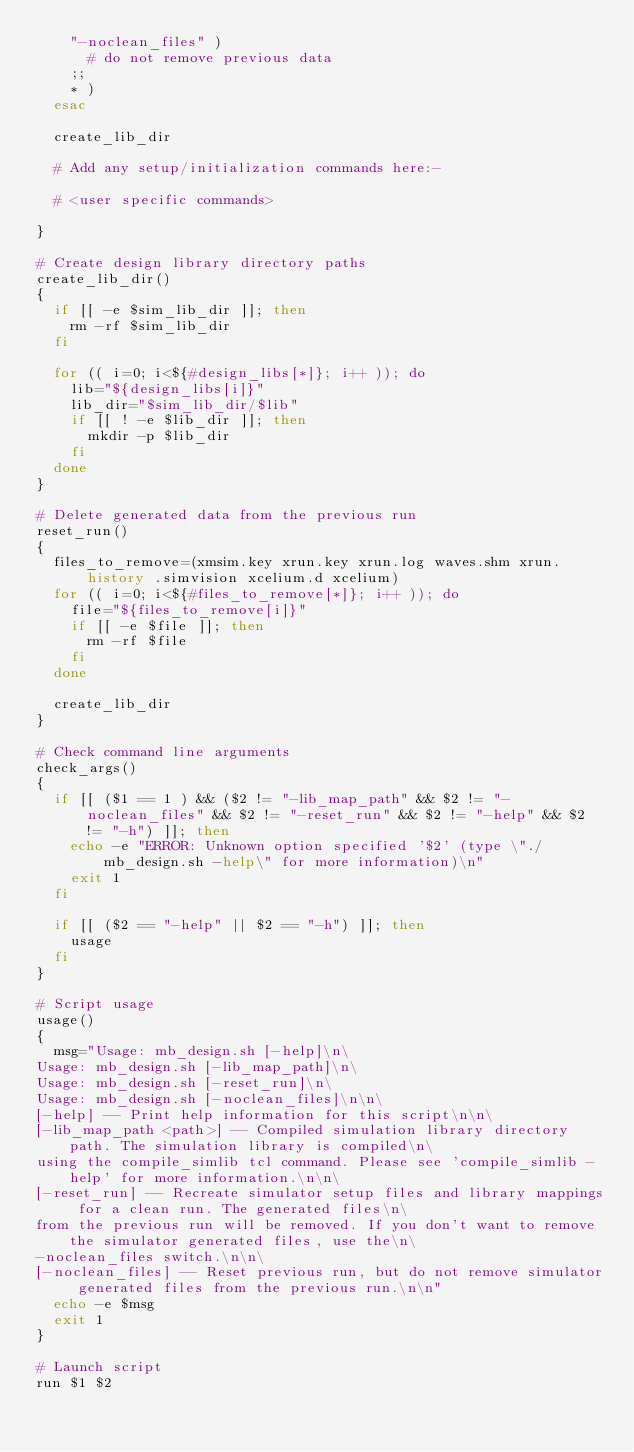<code> <loc_0><loc_0><loc_500><loc_500><_Bash_>    "-noclean_files" )
      # do not remove previous data
    ;;
    * )
  esac

  create_lib_dir

  # Add any setup/initialization commands here:-

  # <user specific commands>

}

# Create design library directory paths
create_lib_dir()
{
  if [[ -e $sim_lib_dir ]]; then
    rm -rf $sim_lib_dir
  fi

  for (( i=0; i<${#design_libs[*]}; i++ )); do
    lib="${design_libs[i]}"
    lib_dir="$sim_lib_dir/$lib"
    if [[ ! -e $lib_dir ]]; then
      mkdir -p $lib_dir
    fi
  done
}

# Delete generated data from the previous run
reset_run()
{
  files_to_remove=(xmsim.key xrun.key xrun.log waves.shm xrun.history .simvision xcelium.d xcelium)
  for (( i=0; i<${#files_to_remove[*]}; i++ )); do
    file="${files_to_remove[i]}"
    if [[ -e $file ]]; then
      rm -rf $file
    fi
  done

  create_lib_dir
}

# Check command line arguments
check_args()
{
  if [[ ($1 == 1 ) && ($2 != "-lib_map_path" && $2 != "-noclean_files" && $2 != "-reset_run" && $2 != "-help" && $2 != "-h") ]]; then
    echo -e "ERROR: Unknown option specified '$2' (type \"./mb_design.sh -help\" for more information)\n"
    exit 1
  fi

  if [[ ($2 == "-help" || $2 == "-h") ]]; then
    usage
  fi
}

# Script usage
usage()
{
  msg="Usage: mb_design.sh [-help]\n\
Usage: mb_design.sh [-lib_map_path]\n\
Usage: mb_design.sh [-reset_run]\n\
Usage: mb_design.sh [-noclean_files]\n\n\
[-help] -- Print help information for this script\n\n\
[-lib_map_path <path>] -- Compiled simulation library directory path. The simulation library is compiled\n\
using the compile_simlib tcl command. Please see 'compile_simlib -help' for more information.\n\n\
[-reset_run] -- Recreate simulator setup files and library mappings for a clean run. The generated files\n\
from the previous run will be removed. If you don't want to remove the simulator generated files, use the\n\
-noclean_files switch.\n\n\
[-noclean_files] -- Reset previous run, but do not remove simulator generated files from the previous run.\n\n"
  echo -e $msg
  exit 1
}

# Launch script
run $1 $2
</code> 